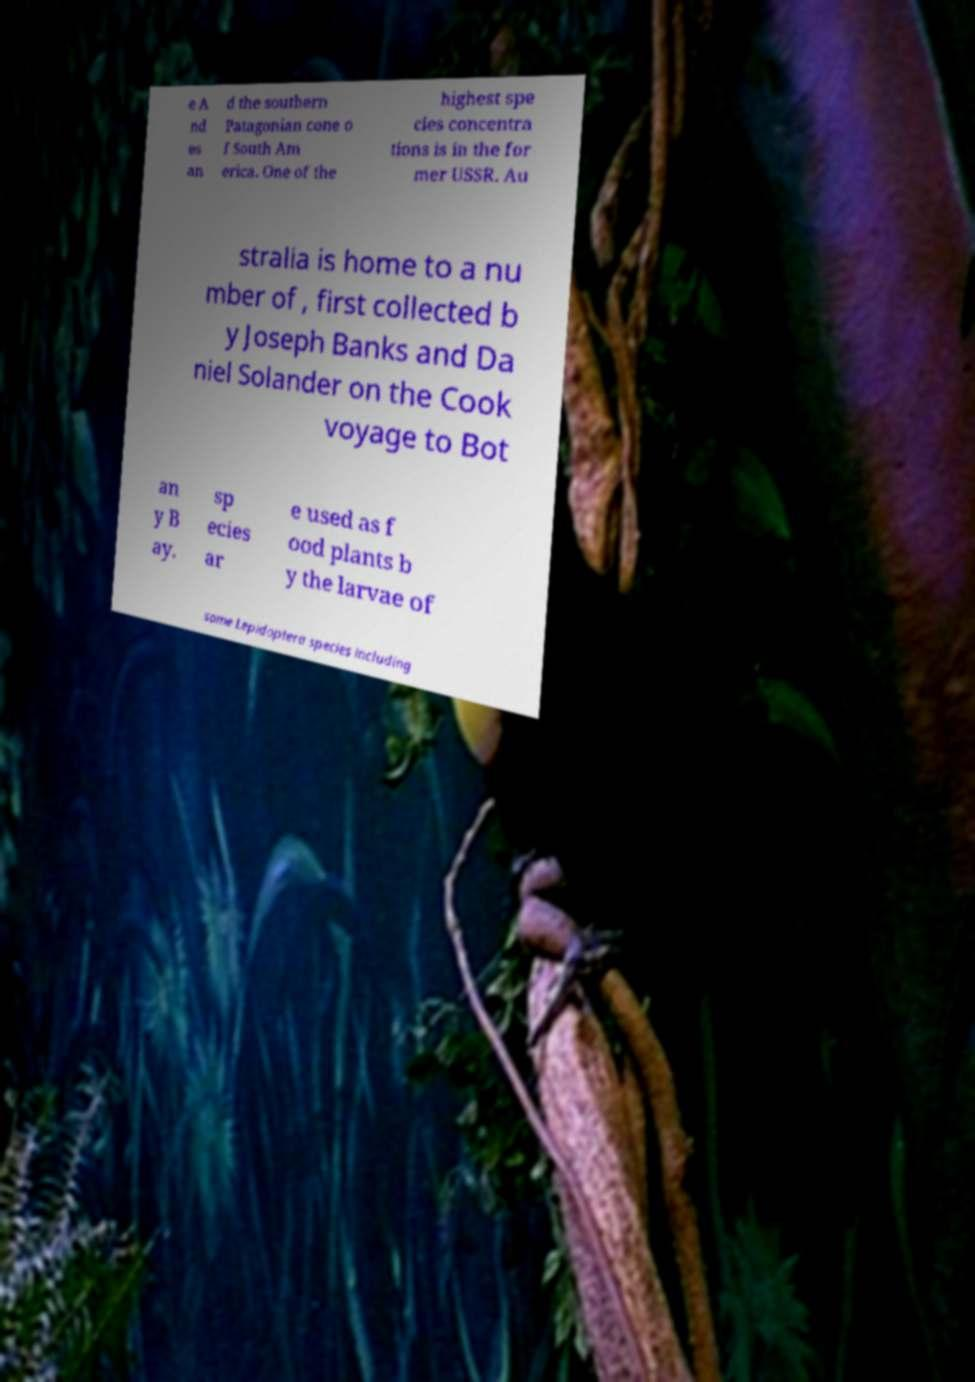Please identify and transcribe the text found in this image. e A nd es an d the southern Patagonian cone o f South Am erica. One of the highest spe cies concentra tions is in the for mer USSR. Au stralia is home to a nu mber of , first collected b y Joseph Banks and Da niel Solander on the Cook voyage to Bot an y B ay. sp ecies ar e used as f ood plants b y the larvae of some Lepidoptera species including 